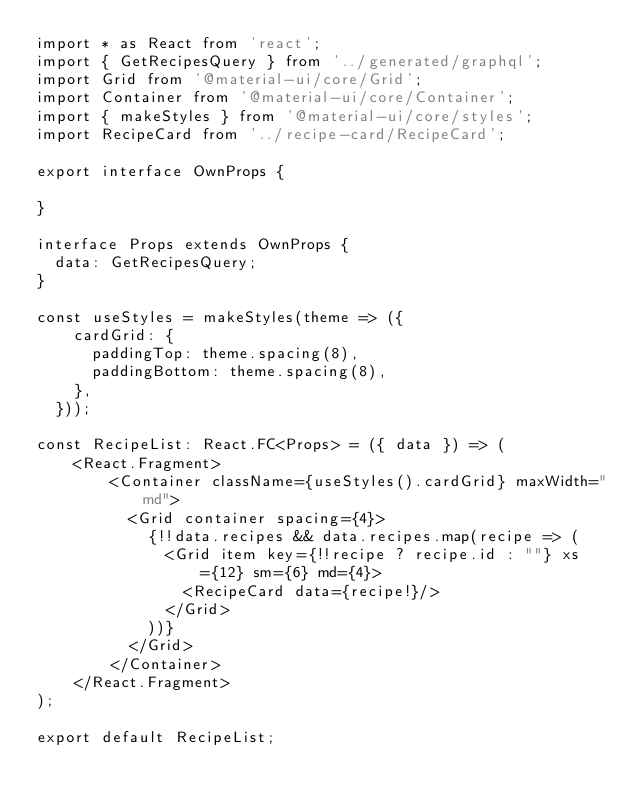<code> <loc_0><loc_0><loc_500><loc_500><_TypeScript_>import * as React from 'react';
import { GetRecipesQuery } from '../generated/graphql';
import Grid from '@material-ui/core/Grid';
import Container from '@material-ui/core/Container';
import { makeStyles } from '@material-ui/core/styles';
import RecipeCard from '../recipe-card/RecipeCard';

export interface OwnProps {

}

interface Props extends OwnProps {
  data: GetRecipesQuery;
}

const useStyles = makeStyles(theme => ({
    cardGrid: {
      paddingTop: theme.spacing(8),
      paddingBottom: theme.spacing(8),
    },
  }));

const RecipeList: React.FC<Props> = ({ data }) => (
    <React.Fragment>
        <Container className={useStyles().cardGrid} maxWidth="md">
          <Grid container spacing={4}>
            {!!data.recipes && data.recipes.map(recipe => (
              <Grid item key={!!recipe ? recipe.id : ""} xs={12} sm={6} md={4}>
                <RecipeCard data={recipe!}/>
              </Grid>
            ))}
          </Grid>
        </Container>
    </React.Fragment>
);

export default RecipeList;
</code> 